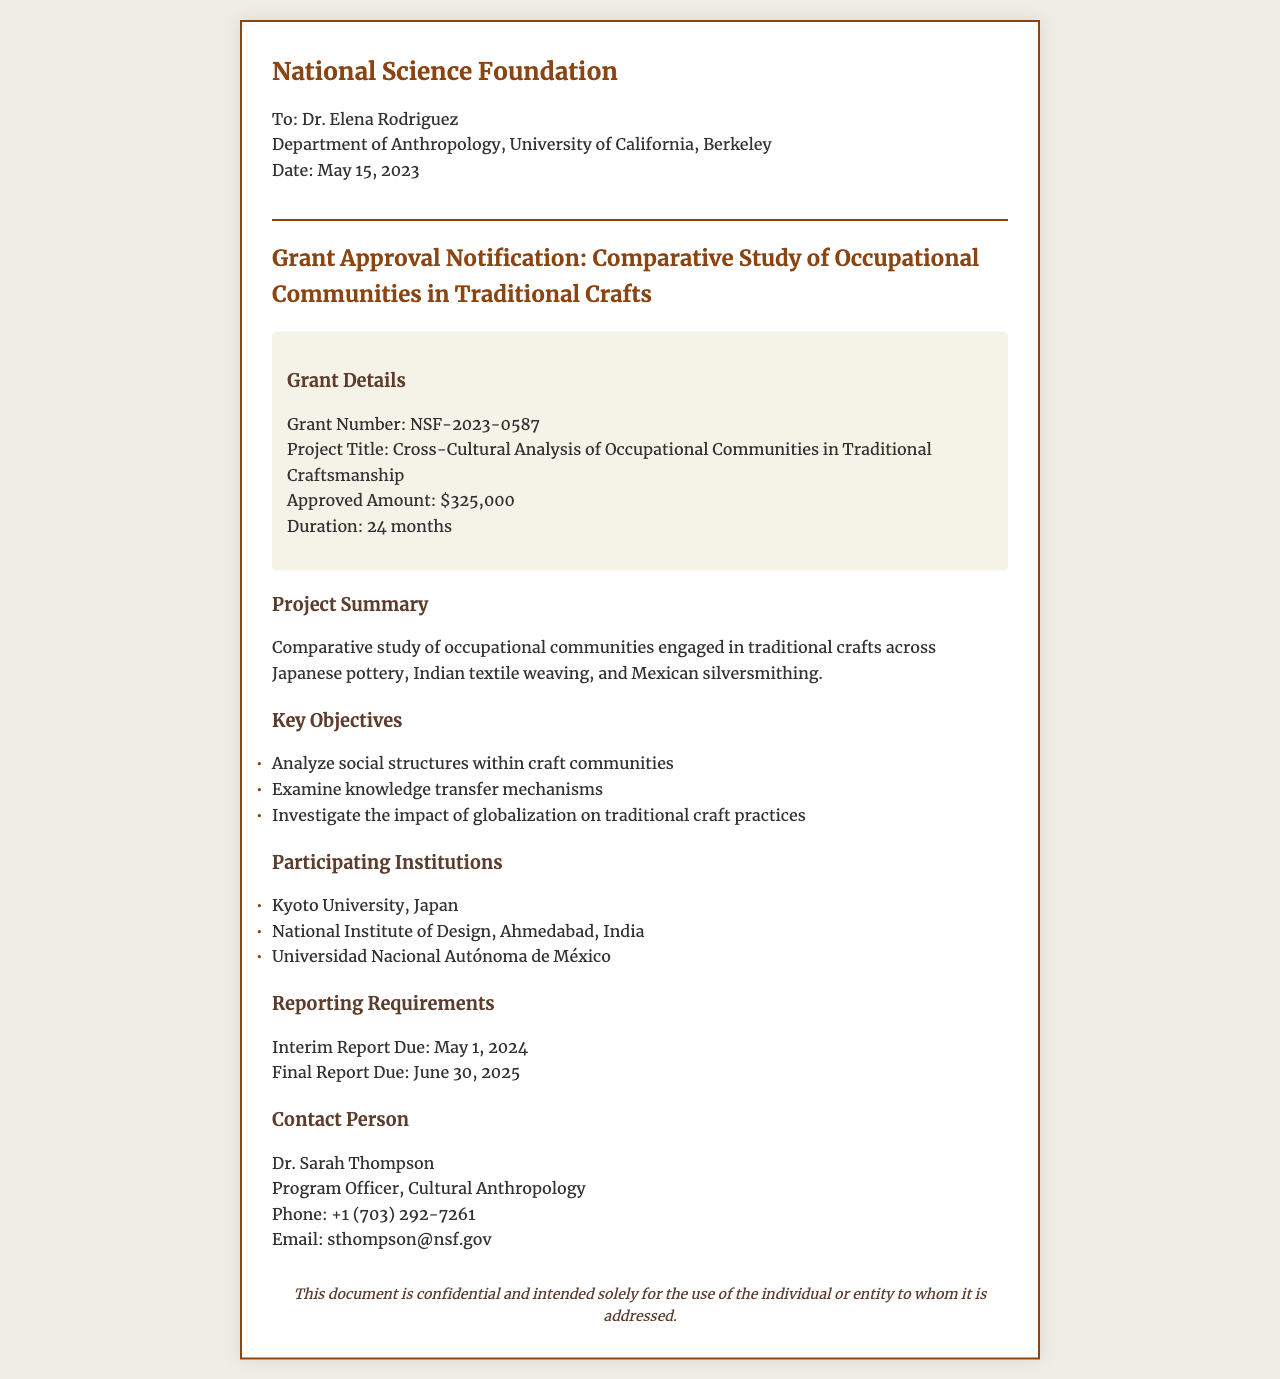What is the grant number? The grant number is explicitly mentioned in the document as NSF-2023-0587.
Answer: NSF-2023-0587 What is the approved amount for the grant? The approved amount is specified in the grant details section of the document as $325,000.
Answer: $325,000 Who is the contact person for this grant? The document provides the name of the contact person, Dr. Sarah Thompson.
Answer: Dr. Sarah Thompson What are the key objectives of the study? The document lists key objectives, including analyzing social structures, examining knowledge transfer mechanisms, and investigating globalization's impact.
Answer: Analyze social structures within craft communities Which institutions are participating in the study? The document enumerates the participating institutions, including Kyoto University, National Institute of Design, and Universidad Nacional Autónoma de México.
Answer: Kyoto University, Japan What is the duration of the project? The duration of the project is stated as 24 months within the grant details.
Answer: 24 months When is the interim report due? The interim report due date is provided in the reporting requirements as May 1, 2024.
Answer: May 1, 2024 What is the project title? The title of the project can be found in the document and is Cross-Cultural Analysis of Occupational Communities in Traditional Craftsmanship.
Answer: Cross-Cultural Analysis of Occupational Communities in Traditional Craftsmanship What kind of document is this? The formatting and structure of the content indicate that this is a grant approval notification fax.
Answer: Grant approval notification fax 